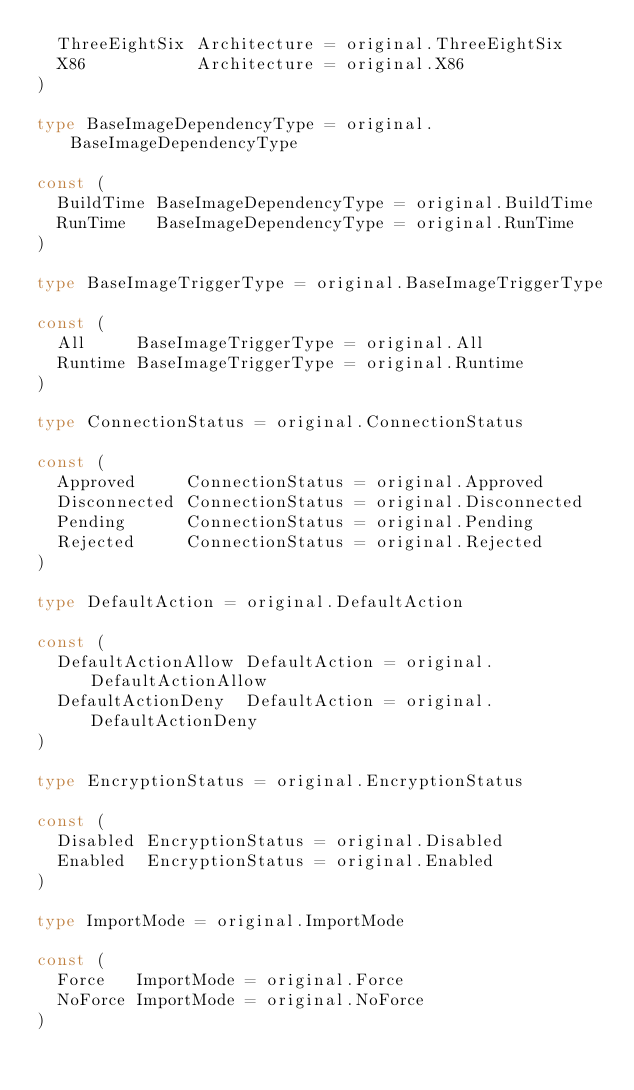Convert code to text. <code><loc_0><loc_0><loc_500><loc_500><_Go_>	ThreeEightSix Architecture = original.ThreeEightSix
	X86           Architecture = original.X86
)

type BaseImageDependencyType = original.BaseImageDependencyType

const (
	BuildTime BaseImageDependencyType = original.BuildTime
	RunTime   BaseImageDependencyType = original.RunTime
)

type BaseImageTriggerType = original.BaseImageTriggerType

const (
	All     BaseImageTriggerType = original.All
	Runtime BaseImageTriggerType = original.Runtime
)

type ConnectionStatus = original.ConnectionStatus

const (
	Approved     ConnectionStatus = original.Approved
	Disconnected ConnectionStatus = original.Disconnected
	Pending      ConnectionStatus = original.Pending
	Rejected     ConnectionStatus = original.Rejected
)

type DefaultAction = original.DefaultAction

const (
	DefaultActionAllow DefaultAction = original.DefaultActionAllow
	DefaultActionDeny  DefaultAction = original.DefaultActionDeny
)

type EncryptionStatus = original.EncryptionStatus

const (
	Disabled EncryptionStatus = original.Disabled
	Enabled  EncryptionStatus = original.Enabled
)

type ImportMode = original.ImportMode

const (
	Force   ImportMode = original.Force
	NoForce ImportMode = original.NoForce
)
</code> 